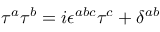<formula> <loc_0><loc_0><loc_500><loc_500>\begin{array} { r } { \tau ^ { a } \tau ^ { b } = i \epsilon ^ { a b c } \tau ^ { c } + \delta ^ { a b } } \end{array}</formula> 